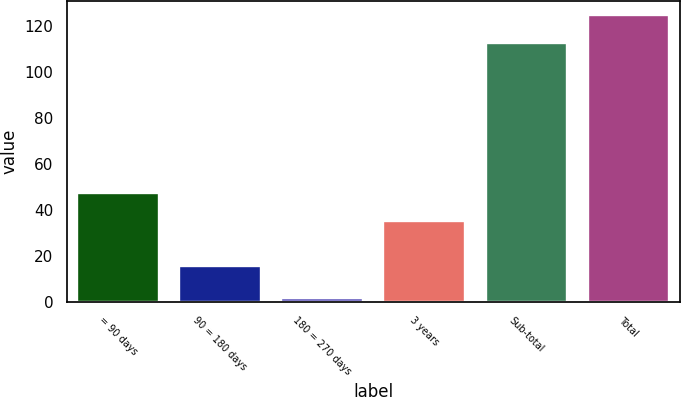Convert chart. <chart><loc_0><loc_0><loc_500><loc_500><bar_chart><fcel>= 90 days<fcel>90 = 180 days<fcel>180 = 270 days<fcel>3 years<fcel>Sub-total<fcel>Total<nl><fcel>47.4<fcel>15.6<fcel>1.6<fcel>35.2<fcel>112.6<fcel>124.8<nl></chart> 